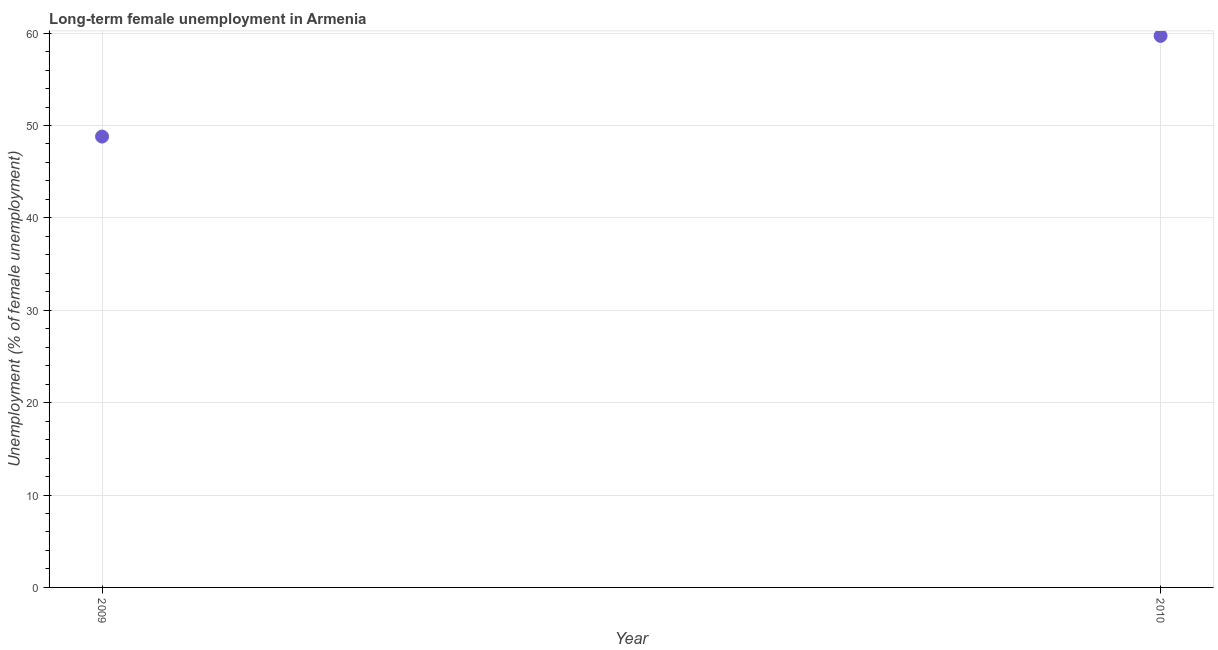What is the long-term female unemployment in 2010?
Provide a short and direct response. 59.7. Across all years, what is the maximum long-term female unemployment?
Keep it short and to the point. 59.7. Across all years, what is the minimum long-term female unemployment?
Keep it short and to the point. 48.8. In which year was the long-term female unemployment maximum?
Offer a terse response. 2010. What is the sum of the long-term female unemployment?
Offer a terse response. 108.5. What is the difference between the long-term female unemployment in 2009 and 2010?
Ensure brevity in your answer.  -10.9. What is the average long-term female unemployment per year?
Keep it short and to the point. 54.25. What is the median long-term female unemployment?
Ensure brevity in your answer.  54.25. Do a majority of the years between 2009 and 2010 (inclusive) have long-term female unemployment greater than 16 %?
Keep it short and to the point. Yes. What is the ratio of the long-term female unemployment in 2009 to that in 2010?
Keep it short and to the point. 0.82. In how many years, is the long-term female unemployment greater than the average long-term female unemployment taken over all years?
Provide a short and direct response. 1. Does the long-term female unemployment monotonically increase over the years?
Provide a short and direct response. Yes. Are the values on the major ticks of Y-axis written in scientific E-notation?
Your response must be concise. No. Does the graph contain grids?
Provide a succinct answer. Yes. What is the title of the graph?
Offer a terse response. Long-term female unemployment in Armenia. What is the label or title of the X-axis?
Your response must be concise. Year. What is the label or title of the Y-axis?
Keep it short and to the point. Unemployment (% of female unemployment). What is the Unemployment (% of female unemployment) in 2009?
Your response must be concise. 48.8. What is the Unemployment (% of female unemployment) in 2010?
Offer a very short reply. 59.7. What is the difference between the Unemployment (% of female unemployment) in 2009 and 2010?
Keep it short and to the point. -10.9. What is the ratio of the Unemployment (% of female unemployment) in 2009 to that in 2010?
Your response must be concise. 0.82. 